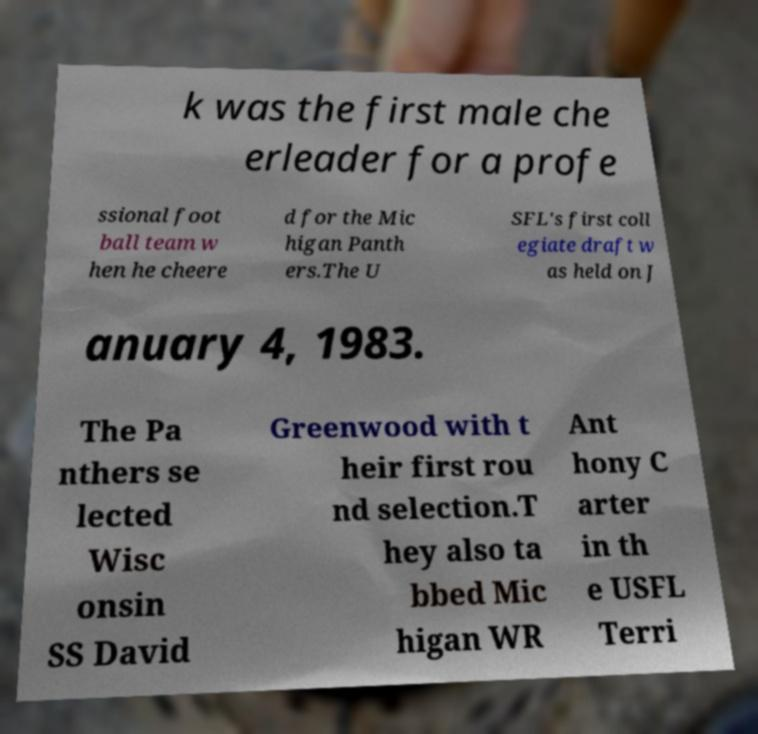What messages or text are displayed in this image? I need them in a readable, typed format. k was the first male che erleader for a profe ssional foot ball team w hen he cheere d for the Mic higan Panth ers.The U SFL's first coll egiate draft w as held on J anuary 4, 1983. The Pa nthers se lected Wisc onsin SS David Greenwood with t heir first rou nd selection.T hey also ta bbed Mic higan WR Ant hony C arter in th e USFL Terri 